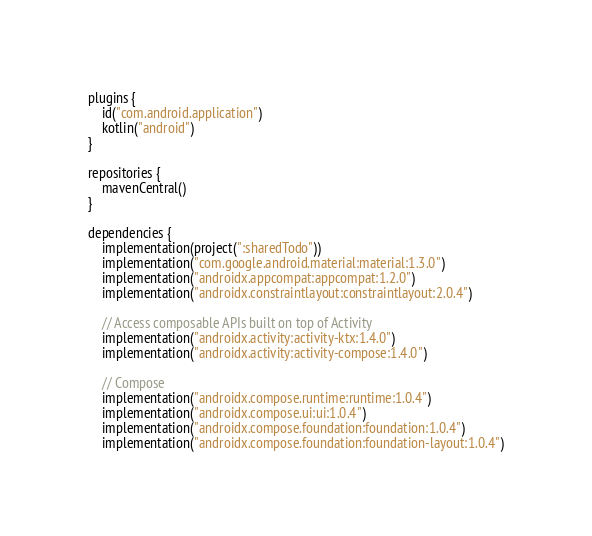Convert code to text. <code><loc_0><loc_0><loc_500><loc_500><_Kotlin_>plugins {
    id("com.android.application")
    kotlin("android")
}

repositories {
    mavenCentral()
}

dependencies {
    implementation(project(":sharedTodo"))
    implementation("com.google.android.material:material:1.3.0")
    implementation("androidx.appcompat:appcompat:1.2.0")
    implementation("androidx.constraintlayout:constraintlayout:2.0.4")
    
    // Access composable APIs built on top of Activity
    implementation("androidx.activity:activity-ktx:1.4.0")
    implementation("androidx.activity:activity-compose:1.4.0")

    // Compose
    implementation("androidx.compose.runtime:runtime:1.0.4")
    implementation("androidx.compose.ui:ui:1.0.4")
    implementation("androidx.compose.foundation:foundation:1.0.4")
    implementation("androidx.compose.foundation:foundation-layout:1.0.4")</code> 